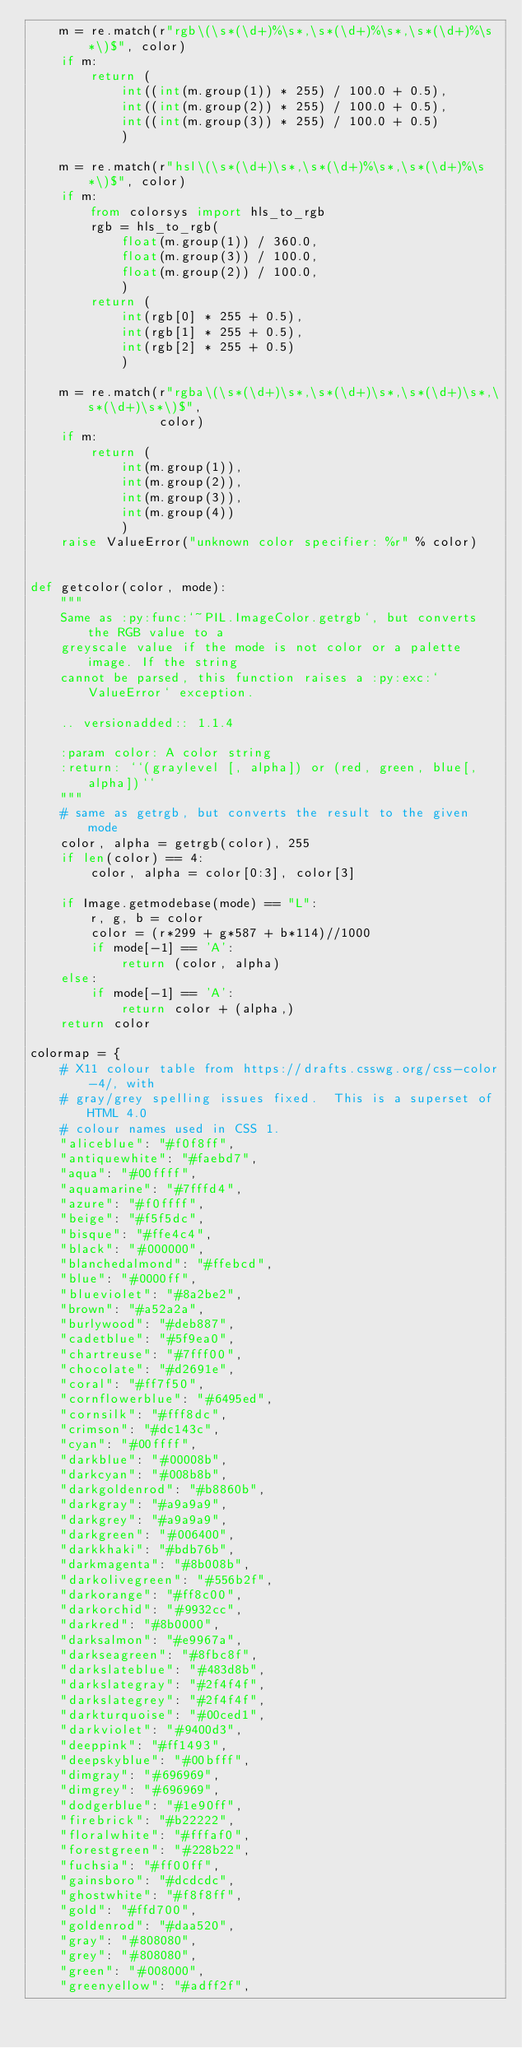Convert code to text. <code><loc_0><loc_0><loc_500><loc_500><_Python_>    m = re.match(r"rgb\(\s*(\d+)%\s*,\s*(\d+)%\s*,\s*(\d+)%\s*\)$", color)
    if m:
        return (
            int((int(m.group(1)) * 255) / 100.0 + 0.5),
            int((int(m.group(2)) * 255) / 100.0 + 0.5),
            int((int(m.group(3)) * 255) / 100.0 + 0.5)
            )

    m = re.match(r"hsl\(\s*(\d+)\s*,\s*(\d+)%\s*,\s*(\d+)%\s*\)$", color)
    if m:
        from colorsys import hls_to_rgb
        rgb = hls_to_rgb(
            float(m.group(1)) / 360.0,
            float(m.group(3)) / 100.0,
            float(m.group(2)) / 100.0,
            )
        return (
            int(rgb[0] * 255 + 0.5),
            int(rgb[1] * 255 + 0.5),
            int(rgb[2] * 255 + 0.5)
            )

    m = re.match(r"rgba\(\s*(\d+)\s*,\s*(\d+)\s*,\s*(\d+)\s*,\s*(\d+)\s*\)$",
                 color)
    if m:
        return (
            int(m.group(1)),
            int(m.group(2)),
            int(m.group(3)),
            int(m.group(4))
            )
    raise ValueError("unknown color specifier: %r" % color)


def getcolor(color, mode):
    """
    Same as :py:func:`~PIL.ImageColor.getrgb`, but converts the RGB value to a
    greyscale value if the mode is not color or a palette image. If the string
    cannot be parsed, this function raises a :py:exc:`ValueError` exception.

    .. versionadded:: 1.1.4

    :param color: A color string
    :return: ``(graylevel [, alpha]) or (red, green, blue[, alpha])``
    """
    # same as getrgb, but converts the result to the given mode
    color, alpha = getrgb(color), 255
    if len(color) == 4:
        color, alpha = color[0:3], color[3]

    if Image.getmodebase(mode) == "L":
        r, g, b = color
        color = (r*299 + g*587 + b*114)//1000
        if mode[-1] == 'A':
            return (color, alpha)
    else:
        if mode[-1] == 'A':
            return color + (alpha,)
    return color

colormap = {
    # X11 colour table from https://drafts.csswg.org/css-color-4/, with
    # gray/grey spelling issues fixed.  This is a superset of HTML 4.0
    # colour names used in CSS 1.
    "aliceblue": "#f0f8ff",
    "antiquewhite": "#faebd7",
    "aqua": "#00ffff",
    "aquamarine": "#7fffd4",
    "azure": "#f0ffff",
    "beige": "#f5f5dc",
    "bisque": "#ffe4c4",
    "black": "#000000",
    "blanchedalmond": "#ffebcd",
    "blue": "#0000ff",
    "blueviolet": "#8a2be2",
    "brown": "#a52a2a",
    "burlywood": "#deb887",
    "cadetblue": "#5f9ea0",
    "chartreuse": "#7fff00",
    "chocolate": "#d2691e",
    "coral": "#ff7f50",
    "cornflowerblue": "#6495ed",
    "cornsilk": "#fff8dc",
    "crimson": "#dc143c",
    "cyan": "#00ffff",
    "darkblue": "#00008b",
    "darkcyan": "#008b8b",
    "darkgoldenrod": "#b8860b",
    "darkgray": "#a9a9a9",
    "darkgrey": "#a9a9a9",
    "darkgreen": "#006400",
    "darkkhaki": "#bdb76b",
    "darkmagenta": "#8b008b",
    "darkolivegreen": "#556b2f",
    "darkorange": "#ff8c00",
    "darkorchid": "#9932cc",
    "darkred": "#8b0000",
    "darksalmon": "#e9967a",
    "darkseagreen": "#8fbc8f",
    "darkslateblue": "#483d8b",
    "darkslategray": "#2f4f4f",
    "darkslategrey": "#2f4f4f",
    "darkturquoise": "#00ced1",
    "darkviolet": "#9400d3",
    "deeppink": "#ff1493",
    "deepskyblue": "#00bfff",
    "dimgray": "#696969",
    "dimgrey": "#696969",
    "dodgerblue": "#1e90ff",
    "firebrick": "#b22222",
    "floralwhite": "#fffaf0",
    "forestgreen": "#228b22",
    "fuchsia": "#ff00ff",
    "gainsboro": "#dcdcdc",
    "ghostwhite": "#f8f8ff",
    "gold": "#ffd700",
    "goldenrod": "#daa520",
    "gray": "#808080",
    "grey": "#808080",
    "green": "#008000",
    "greenyellow": "#adff2f",</code> 